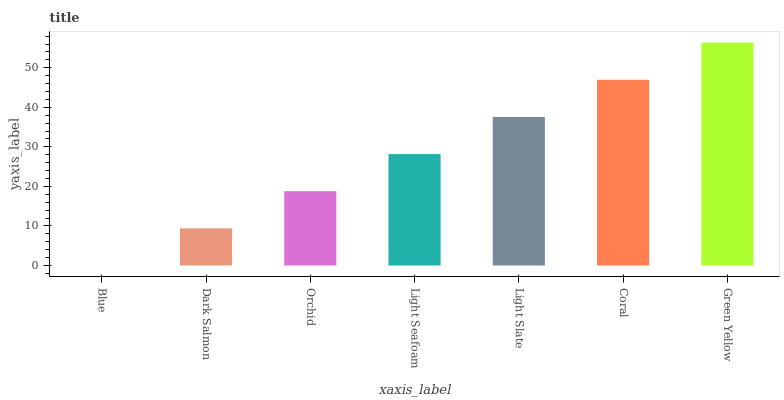Is Dark Salmon the minimum?
Answer yes or no. No. Is Dark Salmon the maximum?
Answer yes or no. No. Is Dark Salmon greater than Blue?
Answer yes or no. Yes. Is Blue less than Dark Salmon?
Answer yes or no. Yes. Is Blue greater than Dark Salmon?
Answer yes or no. No. Is Dark Salmon less than Blue?
Answer yes or no. No. Is Light Seafoam the high median?
Answer yes or no. Yes. Is Light Seafoam the low median?
Answer yes or no. Yes. Is Orchid the high median?
Answer yes or no. No. Is Orchid the low median?
Answer yes or no. No. 